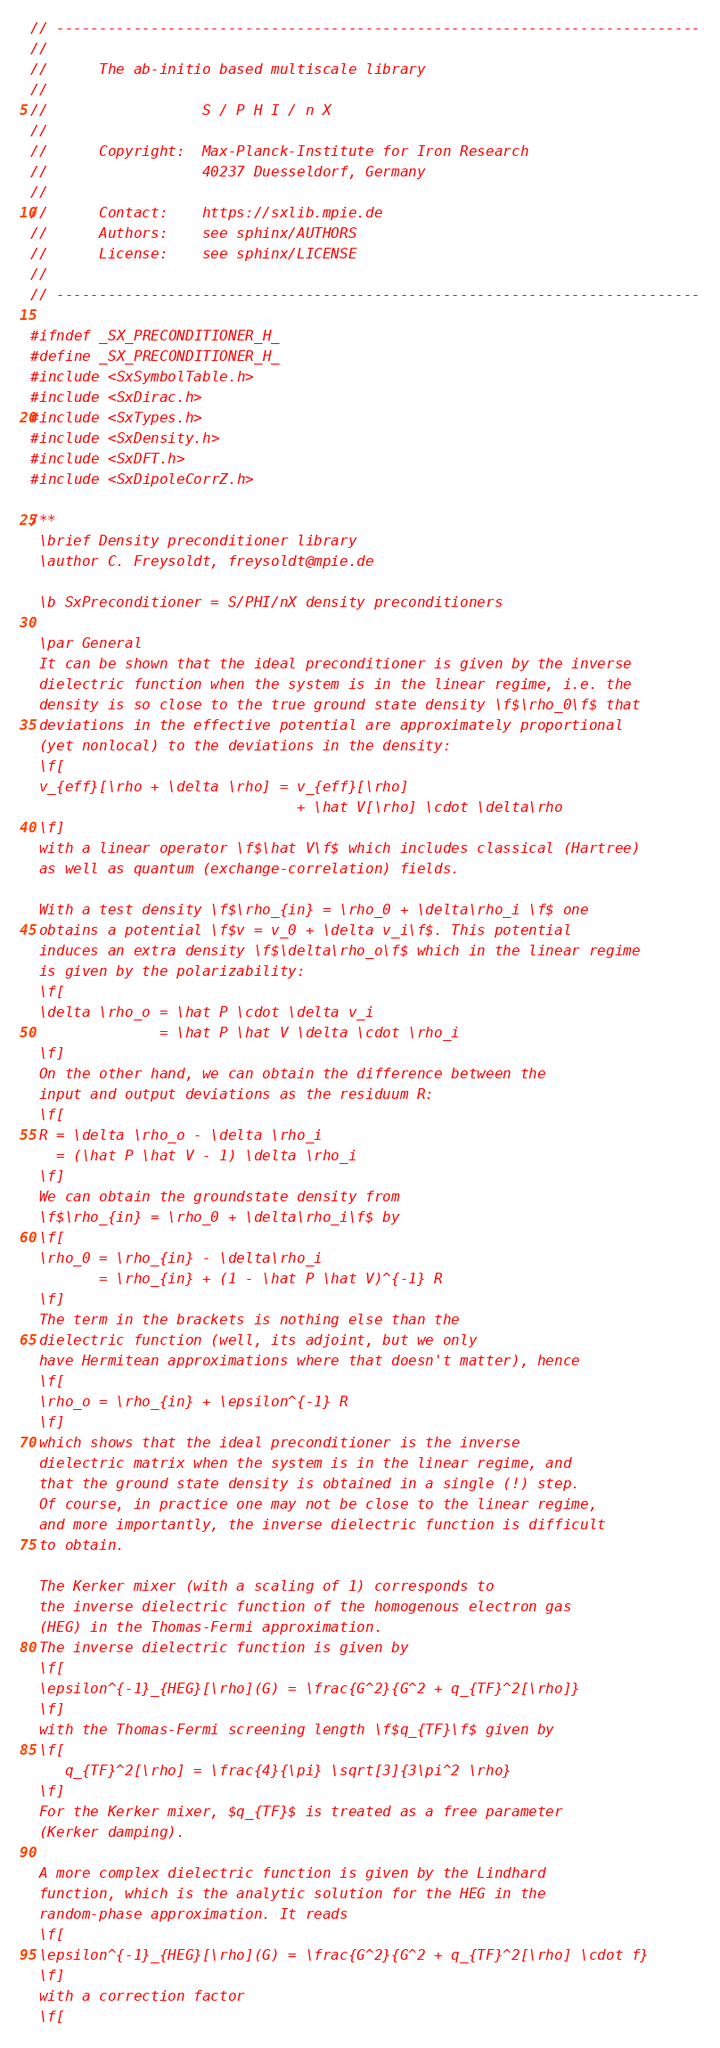Convert code to text. <code><loc_0><loc_0><loc_500><loc_500><_C_>// ---------------------------------------------------------------------------
//
//      The ab-initio based multiscale library
//
//                  S / P H I / n X
//
//      Copyright:  Max-Planck-Institute for Iron Research
//                  40237 Duesseldorf, Germany
//
//      Contact:    https://sxlib.mpie.de
//      Authors:    see sphinx/AUTHORS
//      License:    see sphinx/LICENSE
//
// ---------------------------------------------------------------------------

#ifndef _SX_PRECONDITIONER_H_
#define _SX_PRECONDITIONER_H_
#include <SxSymbolTable.h>
#include <SxDirac.h>
#include <SxTypes.h>
#include <SxDensity.h>
#include <SxDFT.h>
#include <SxDipoleCorrZ.h>

/**
 \brief Density preconditioner library
 \author C. Freysoldt, freysoldt@mpie.de

 \b SxPreconditioner = S/PHI/nX density preconditioners
 
 \par General
 It can be shown that the ideal preconditioner is given by the inverse
 dielectric function when the system is in the linear regime, i.e. the
 density is so close to the true ground state density \f$\rho_0\f$ that
 deviations in the effective potential are approximately proportional
 (yet nonlocal) to the deviations in the density:
 \f[
 v_{eff}[\rho + \delta \rho] = v_{eff}[\rho] 
                               + \hat V[\rho] \cdot \delta\rho
 \f]
 with a linear operator \f$\hat V\f$ which includes classical (Hartree)
 as well as quantum (exchange-correlation) fields.

 With a test density \f$\rho_{in} = \rho_0 + \delta\rho_i \f$ one
 obtains a potential \f$v = v_0 + \delta v_i\f$. This potential
 induces an extra density \f$\delta\rho_o\f$ which in the linear regime
 is given by the polarizability:
 \f[
 \delta \rho_o = \hat P \cdot \delta v_i 
               = \hat P \hat V \delta \cdot \rho_i
 \f]
 On the other hand, we can obtain the difference between the
 input and output deviations as the residuum R:
 \f[
 R = \delta \rho_o - \delta \rho_i 
   = (\hat P \hat V - 1) \delta \rho_i
 \f]
 We can obtain the groundstate density from 
 \f$\rho_{in} = \rho_0 + \delta\rho_i\f$ by
 \f[
 \rho_0 = \rho_{in} - \delta\rho_i
        = \rho_{in} + (1 - \hat P \hat V)^{-1} R
 \f]
 The term in the brackets is nothing else than the 
 dielectric function (well, its adjoint, but we only
 have Hermitean approximations where that doesn't matter), hence
 \f[
 \rho_o = \rho_{in} + \epsilon^{-1} R
 \f]
 which shows that the ideal preconditioner is the inverse
 dielectric matrix when the system is in the linear regime, and
 that the ground state density is obtained in a single (!) step.
 Of course, in practice one may not be close to the linear regime,
 and more importantly, the inverse dielectric function is difficult
 to obtain.

 The Kerker mixer (with a scaling of 1) corresponds to
 the inverse dielectric function of the homogenous electron gas
 (HEG) in the Thomas-Fermi approximation.
 The inverse dielectric function is given by
 \f[
 \epsilon^{-1}_{HEG}[\rho](G) = \frac{G^2}{G^2 + q_{TF}^2[\rho]}
 \f]
 with the Thomas-Fermi screening length \f$q_{TF}\f$ given by
 \f[
    q_{TF}^2[\rho] = \frac{4}{\pi} \sqrt[3]{3\pi^2 \rho}
 \f]
 For the Kerker mixer, $q_{TF}$ is treated as a free parameter
 (Kerker damping).

 A more complex dielectric function is given by the Lindhard
 function, which is the analytic solution for the HEG in the 
 random-phase approximation. It reads
 \f[
 \epsilon^{-1}_{HEG}[\rho](G) = \frac{G^2}{G^2 + q_{TF}^2[\rho] \cdot f}
 \f]
 with a correction factor
 \f[</code> 